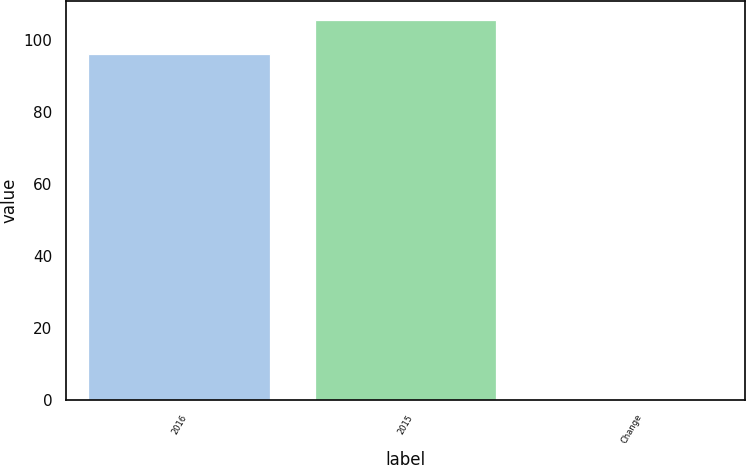Convert chart to OTSL. <chart><loc_0><loc_0><loc_500><loc_500><bar_chart><fcel>2016<fcel>2015<fcel>Change<nl><fcel>96<fcel>105.6<fcel>0.1<nl></chart> 